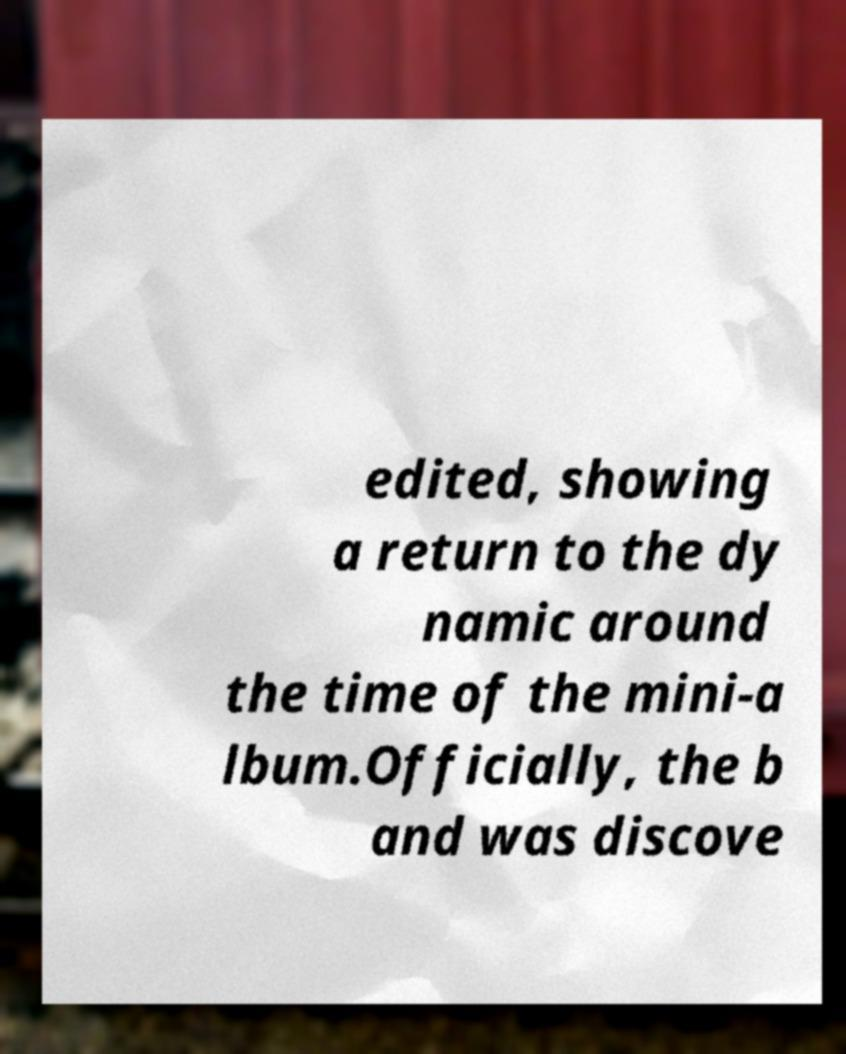Could you assist in decoding the text presented in this image and type it out clearly? edited, showing a return to the dy namic around the time of the mini-a lbum.Officially, the b and was discove 